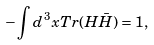<formula> <loc_0><loc_0><loc_500><loc_500>- \int d ^ { 3 } x T r ( H \bar { H } ) = 1 ,</formula> 